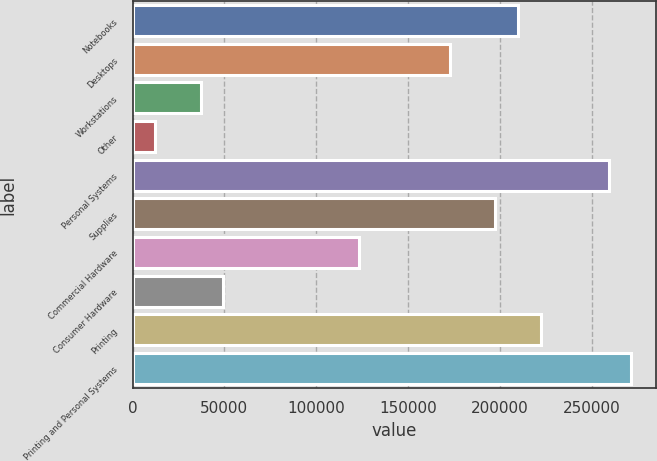Convert chart to OTSL. <chart><loc_0><loc_0><loc_500><loc_500><bar_chart><fcel>Notebooks<fcel>Desktops<fcel>Workstations<fcel>Other<fcel>Personal Systems<fcel>Supplies<fcel>Commercial Hardware<fcel>Consumer Hardware<fcel>Printing<fcel>Printing and Personal Systems<nl><fcel>209972<fcel>172929<fcel>37101.7<fcel>12405.9<fcel>259364<fcel>197624<fcel>123537<fcel>49449.6<fcel>222320<fcel>271712<nl></chart> 